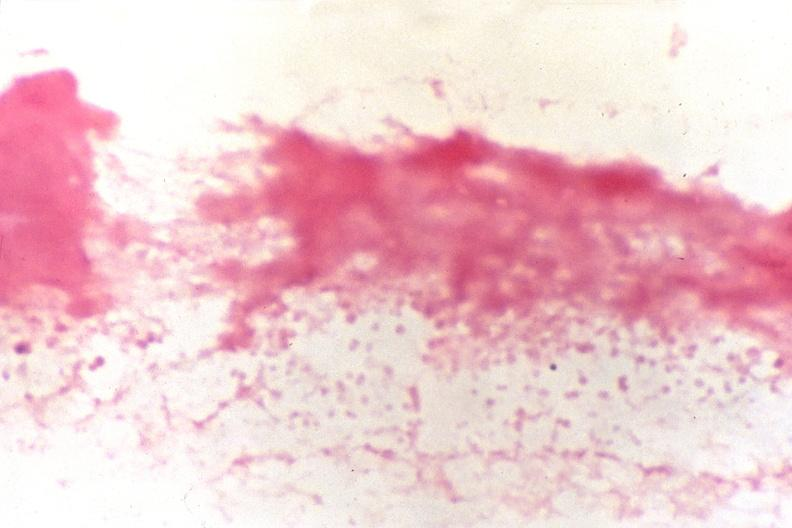does electron micrographs demonstrating fiber stain?
Answer the question using a single word or phrase. No 